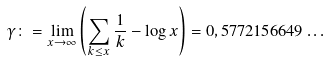<formula> <loc_0><loc_0><loc_500><loc_500>\gamma \colon = \lim _ { x \rightarrow \infty } \left ( \sum _ { k \leq x } \frac { 1 } { k } - \log x \right ) = 0 , 5 7 7 2 1 5 6 6 4 9 \dots</formula> 